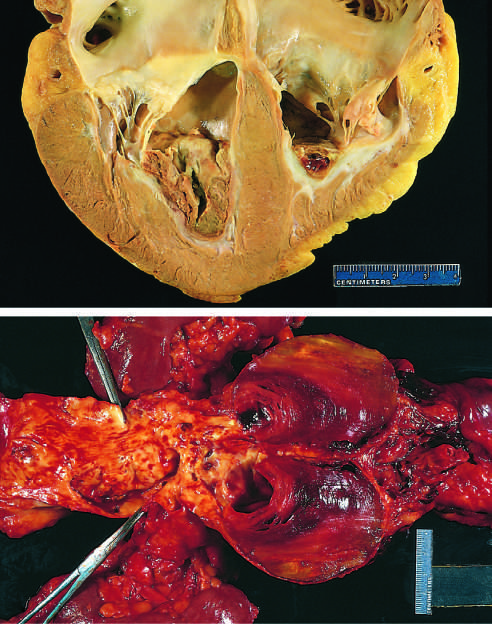re margin p also super-imposed on advanced atherosclerotic lesions of the more proximal aorta (left side of photograph)?
Answer the question using a single word or phrase. No 